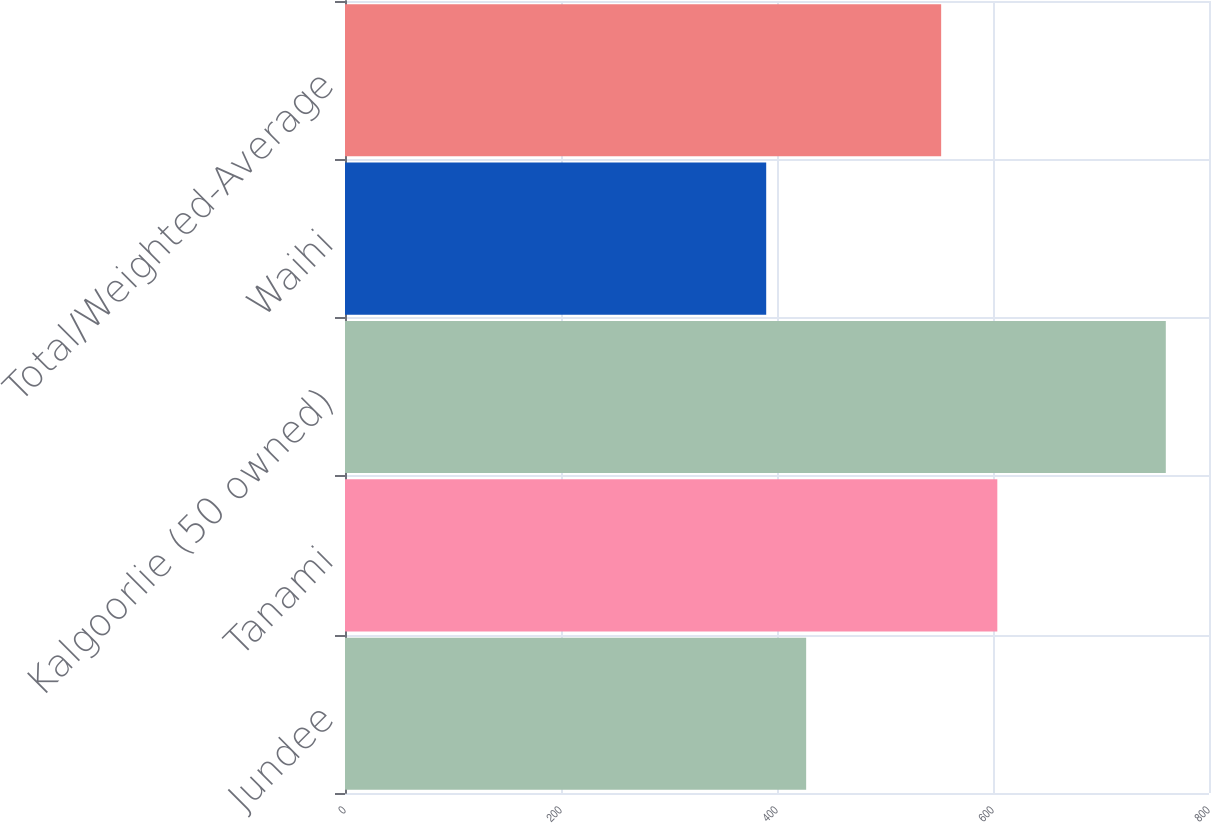<chart> <loc_0><loc_0><loc_500><loc_500><bar_chart><fcel>Jundee<fcel>Tanami<fcel>Kalgoorlie (50 owned)<fcel>Waihi<fcel>Total/Weighted-Average<nl><fcel>427<fcel>604<fcel>760<fcel>390<fcel>552<nl></chart> 